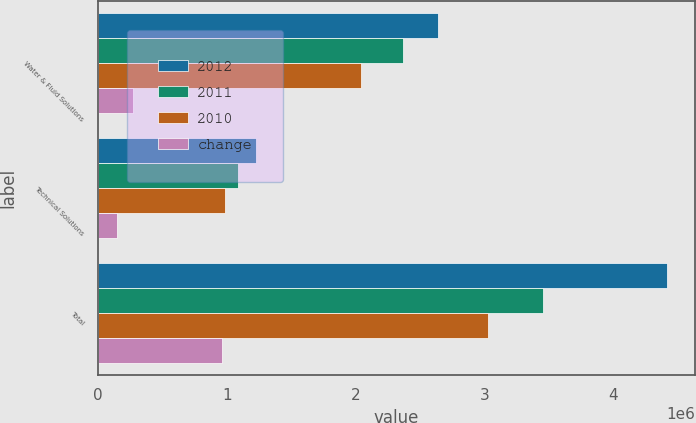Convert chart to OTSL. <chart><loc_0><loc_0><loc_500><loc_500><stacked_bar_chart><ecel><fcel>Water & Fluid Solutions<fcel>Technical Solutions<fcel>Total<nl><fcel>2012<fcel>2.6384e+06<fcel>1.23104e+06<fcel>4.41615e+06<nl><fcel>2011<fcel>2.3698e+06<fcel>1.08688e+06<fcel>3.45669e+06<nl><fcel>2010<fcel>2.04128e+06<fcel>989492<fcel>3.03077e+06<nl><fcel>change<fcel>268599<fcel>144154<fcel>959460<nl></chart> 